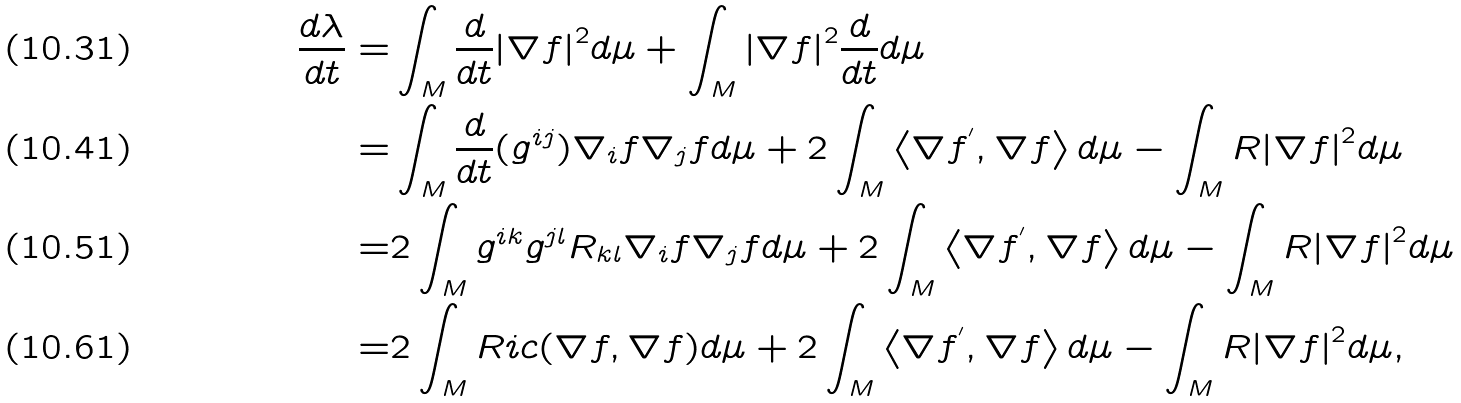Convert formula to latex. <formula><loc_0><loc_0><loc_500><loc_500>\frac { d \lambda } { d t } = & \int _ { M } \frac { d } { d t } { \left | \nabla f \right | } ^ { 2 } d \mu + \int _ { M } { \left | \nabla f \right | } ^ { 2 } \frac { d } { d t } d \mu \\ = & \int _ { M } \frac { d } { d t } ( g ^ { i j } ) \nabla _ { i } f \nabla _ { j } f d \mu + 2 \int _ { M } \left \langle \nabla f ^ { ^ { \prime } } , \nabla f \right \rangle d \mu - \int _ { M } R { \left | \nabla f \right | } ^ { 2 } d \mu \\ = & 2 \int _ { M } g ^ { i k } g ^ { j l } R _ { k l } \nabla _ { i } f \nabla _ { j } f d \mu + 2 \int _ { M } \left \langle \nabla f ^ { ^ { \prime } } , \nabla f \right \rangle d \mu - \int _ { M } R { \left | \nabla f \right | } ^ { 2 } d \mu \\ = & 2 \int _ { M } R i c ( \nabla f , \nabla f ) d \mu + 2 \int _ { M } \left \langle \nabla f ^ { ^ { \prime } } , \nabla f \right \rangle d \mu - \int _ { M } R { \left | \nabla f \right | } ^ { 2 } d \mu ,</formula> 